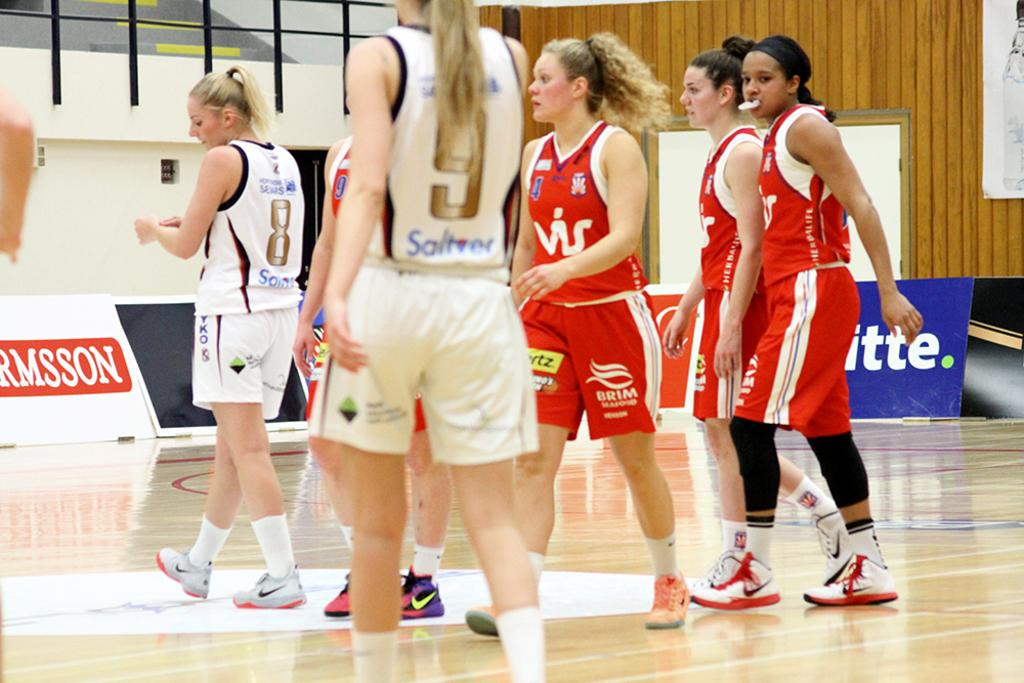What is the main subject of the image? The main subject of the image is a group of persons. What can be seen in the background of the image? There is a wall in the background of the image. What else is present in the image besides the group of persons and the wall? There are advertising boards present behind the group of persons. Can you tell me how many rabbits are sitting on the advertising boards in the image? There are no rabbits present in the image; only the group of persons, the wall, and the advertising boards can be seen. 